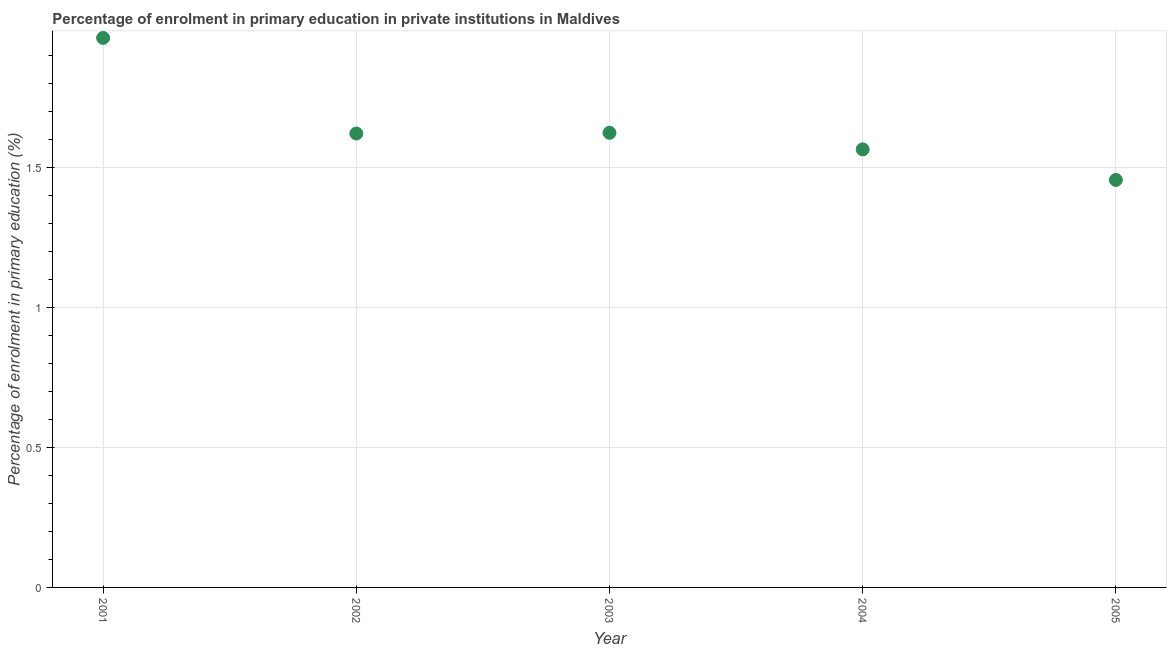What is the enrolment percentage in primary education in 2002?
Give a very brief answer. 1.62. Across all years, what is the maximum enrolment percentage in primary education?
Give a very brief answer. 1.96. Across all years, what is the minimum enrolment percentage in primary education?
Your answer should be very brief. 1.45. In which year was the enrolment percentage in primary education maximum?
Make the answer very short. 2001. In which year was the enrolment percentage in primary education minimum?
Keep it short and to the point. 2005. What is the sum of the enrolment percentage in primary education?
Provide a succinct answer. 8.22. What is the difference between the enrolment percentage in primary education in 2003 and 2004?
Keep it short and to the point. 0.06. What is the average enrolment percentage in primary education per year?
Offer a terse response. 1.64. What is the median enrolment percentage in primary education?
Your response must be concise. 1.62. In how many years, is the enrolment percentage in primary education greater than 0.6 %?
Provide a short and direct response. 5. Do a majority of the years between 2002 and 2004 (inclusive) have enrolment percentage in primary education greater than 1.5 %?
Your answer should be very brief. Yes. What is the ratio of the enrolment percentage in primary education in 2002 to that in 2003?
Ensure brevity in your answer.  1. Is the enrolment percentage in primary education in 2001 less than that in 2004?
Provide a succinct answer. No. What is the difference between the highest and the second highest enrolment percentage in primary education?
Keep it short and to the point. 0.34. Is the sum of the enrolment percentage in primary education in 2002 and 2005 greater than the maximum enrolment percentage in primary education across all years?
Make the answer very short. Yes. What is the difference between the highest and the lowest enrolment percentage in primary education?
Give a very brief answer. 0.51. In how many years, is the enrolment percentage in primary education greater than the average enrolment percentage in primary education taken over all years?
Your answer should be compact. 1. Are the values on the major ticks of Y-axis written in scientific E-notation?
Make the answer very short. No. Does the graph contain any zero values?
Ensure brevity in your answer.  No. Does the graph contain grids?
Your answer should be compact. Yes. What is the title of the graph?
Provide a succinct answer. Percentage of enrolment in primary education in private institutions in Maldives. What is the label or title of the X-axis?
Offer a terse response. Year. What is the label or title of the Y-axis?
Give a very brief answer. Percentage of enrolment in primary education (%). What is the Percentage of enrolment in primary education (%) in 2001?
Ensure brevity in your answer.  1.96. What is the Percentage of enrolment in primary education (%) in 2002?
Keep it short and to the point. 1.62. What is the Percentage of enrolment in primary education (%) in 2003?
Keep it short and to the point. 1.62. What is the Percentage of enrolment in primary education (%) in 2004?
Offer a very short reply. 1.56. What is the Percentage of enrolment in primary education (%) in 2005?
Your answer should be compact. 1.45. What is the difference between the Percentage of enrolment in primary education (%) in 2001 and 2002?
Offer a terse response. 0.34. What is the difference between the Percentage of enrolment in primary education (%) in 2001 and 2003?
Your response must be concise. 0.34. What is the difference between the Percentage of enrolment in primary education (%) in 2001 and 2004?
Provide a succinct answer. 0.4. What is the difference between the Percentage of enrolment in primary education (%) in 2001 and 2005?
Ensure brevity in your answer.  0.51. What is the difference between the Percentage of enrolment in primary education (%) in 2002 and 2003?
Offer a terse response. -0. What is the difference between the Percentage of enrolment in primary education (%) in 2002 and 2004?
Provide a short and direct response. 0.06. What is the difference between the Percentage of enrolment in primary education (%) in 2002 and 2005?
Ensure brevity in your answer.  0.17. What is the difference between the Percentage of enrolment in primary education (%) in 2003 and 2004?
Give a very brief answer. 0.06. What is the difference between the Percentage of enrolment in primary education (%) in 2003 and 2005?
Ensure brevity in your answer.  0.17. What is the difference between the Percentage of enrolment in primary education (%) in 2004 and 2005?
Make the answer very short. 0.11. What is the ratio of the Percentage of enrolment in primary education (%) in 2001 to that in 2002?
Make the answer very short. 1.21. What is the ratio of the Percentage of enrolment in primary education (%) in 2001 to that in 2003?
Provide a short and direct response. 1.21. What is the ratio of the Percentage of enrolment in primary education (%) in 2001 to that in 2004?
Ensure brevity in your answer.  1.25. What is the ratio of the Percentage of enrolment in primary education (%) in 2001 to that in 2005?
Make the answer very short. 1.35. What is the ratio of the Percentage of enrolment in primary education (%) in 2002 to that in 2003?
Give a very brief answer. 1. What is the ratio of the Percentage of enrolment in primary education (%) in 2002 to that in 2004?
Provide a short and direct response. 1.04. What is the ratio of the Percentage of enrolment in primary education (%) in 2002 to that in 2005?
Your answer should be compact. 1.11. What is the ratio of the Percentage of enrolment in primary education (%) in 2003 to that in 2004?
Your answer should be very brief. 1.04. What is the ratio of the Percentage of enrolment in primary education (%) in 2003 to that in 2005?
Keep it short and to the point. 1.12. What is the ratio of the Percentage of enrolment in primary education (%) in 2004 to that in 2005?
Provide a short and direct response. 1.07. 